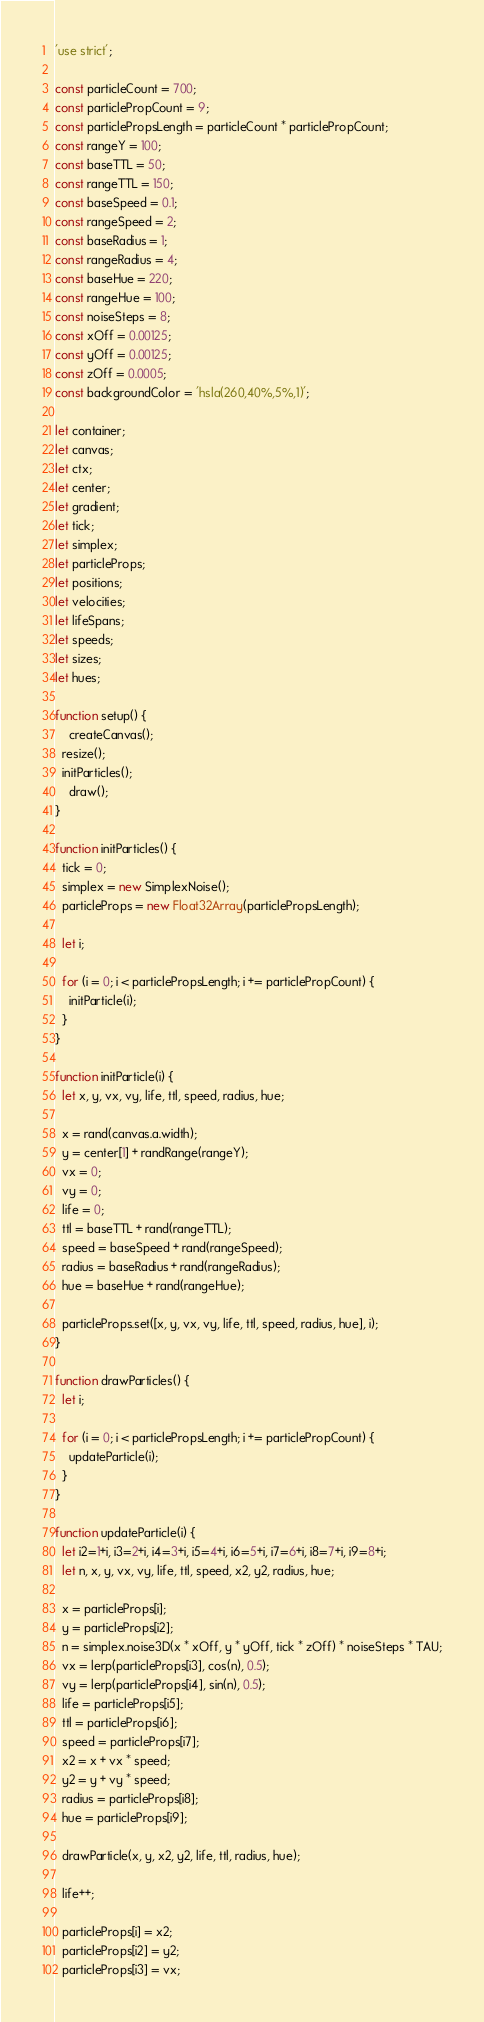Convert code to text. <code><loc_0><loc_0><loc_500><loc_500><_JavaScript_>'use strict';

const particleCount = 700;
const particlePropCount = 9;
const particlePropsLength = particleCount * particlePropCount;
const rangeY = 100;
const baseTTL = 50;
const rangeTTL = 150;
const baseSpeed = 0.1;
const rangeSpeed = 2;
const baseRadius = 1;
const rangeRadius = 4;
const baseHue = 220;
const rangeHue = 100;
const noiseSteps = 8;
const xOff = 0.00125;
const yOff = 0.00125;
const zOff = 0.0005;
const backgroundColor = 'hsla(260,40%,5%,1)';

let container;
let canvas;
let ctx;
let center;
let gradient;
let tick;
let simplex;
let particleProps;
let positions;
let velocities;
let lifeSpans;
let speeds;
let sizes;
let hues;

function setup() {
	createCanvas();
  resize();
  initParticles();
	draw();
}

function initParticles() {
  tick = 0;
  simplex = new SimplexNoise();
  particleProps = new Float32Array(particlePropsLength);

  let i;
  
  for (i = 0; i < particlePropsLength; i += particlePropCount) {
    initParticle(i);
  }
}

function initParticle(i) {
  let x, y, vx, vy, life, ttl, speed, radius, hue;

  x = rand(canvas.a.width);
  y = center[1] + randRange(rangeY);
  vx = 0;
  vy = 0;
  life = 0;
  ttl = baseTTL + rand(rangeTTL);
  speed = baseSpeed + rand(rangeSpeed);
  radius = baseRadius + rand(rangeRadius);
  hue = baseHue + rand(rangeHue);

  particleProps.set([x, y, vx, vy, life, ttl, speed, radius, hue], i);
}

function drawParticles() {
  let i;

  for (i = 0; i < particlePropsLength; i += particlePropCount) {
    updateParticle(i);
  }
}

function updateParticle(i) {
  let i2=1+i, i3=2+i, i4=3+i, i5=4+i, i6=5+i, i7=6+i, i8=7+i, i9=8+i;
  let n, x, y, vx, vy, life, ttl, speed, x2, y2, radius, hue;

  x = particleProps[i];
  y = particleProps[i2];
  n = simplex.noise3D(x * xOff, y * yOff, tick * zOff) * noiseSteps * TAU;
  vx = lerp(particleProps[i3], cos(n), 0.5);
  vy = lerp(particleProps[i4], sin(n), 0.5);
  life = particleProps[i5];
  ttl = particleProps[i6];
  speed = particleProps[i7];
  x2 = x + vx * speed;
  y2 = y + vy * speed;
  radius = particleProps[i8];
  hue = particleProps[i9];

  drawParticle(x, y, x2, y2, life, ttl, radius, hue);

  life++;

  particleProps[i] = x2;
  particleProps[i2] = y2;
  particleProps[i3] = vx;</code> 